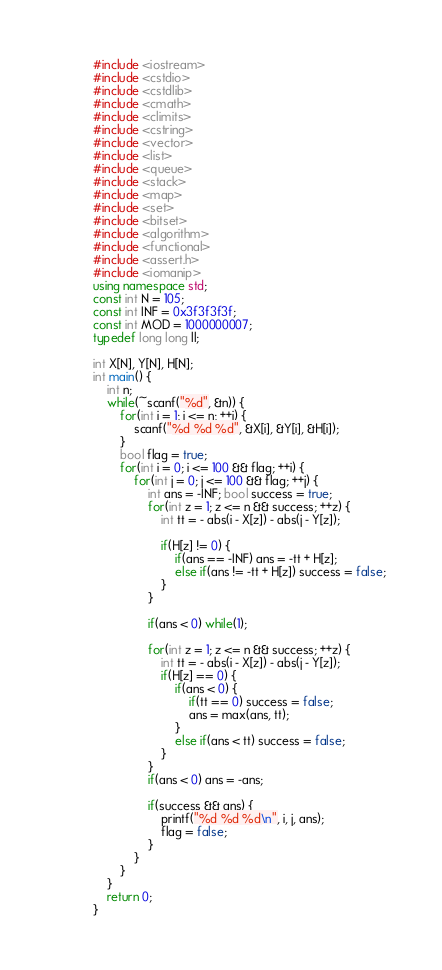<code> <loc_0><loc_0><loc_500><loc_500><_C++_>#include <iostream>
#include <cstdio>
#include <cstdlib>
#include <cmath>
#include <climits>
#include <cstring>
#include <vector>
#include <list>
#include <queue>
#include <stack>
#include <map>
#include <set>
#include <bitset>
#include <algorithm>
#include <functional>
#include <assert.h>
#include <iomanip>
using namespace std;
const int N = 105;
const int INF = 0x3f3f3f3f;
const int MOD = 1000000007;
typedef long long ll;

int X[N], Y[N], H[N];
int main() {
    int n;
    while(~scanf("%d", &n)) {
        for(int i = 1; i <= n; ++i) {
            scanf("%d %d %d", &X[i], &Y[i], &H[i]);
        }
        bool flag = true;
        for(int i = 0; i <= 100 && flag; ++i) {
            for(int j = 0; j <= 100 && flag; ++j) {
                int ans = -INF; bool success = true;
                for(int z = 1; z <= n && success; ++z) {
                    int tt = - abs(i - X[z]) - abs(j - Y[z]);

                    if(H[z] != 0) {
                        if(ans == -INF) ans = -tt + H[z];
                        else if(ans != -tt + H[z]) success = false;
                    }
                }

                if(ans < 0) while(1);

                for(int z = 1; z <= n && success; ++z) {
                    int tt = - abs(i - X[z]) - abs(j - Y[z]);
                    if(H[z] == 0) {
                        if(ans < 0) {
                            if(tt == 0) success = false;
                            ans = max(ans, tt);
                        }
                        else if(ans < tt) success = false;
                    }
                }
                if(ans < 0) ans = -ans;

                if(success && ans) {
                    printf("%d %d %d\n", i, j, ans);
                    flag = false;
                }
            }
        }
    }
    return 0;
}</code> 